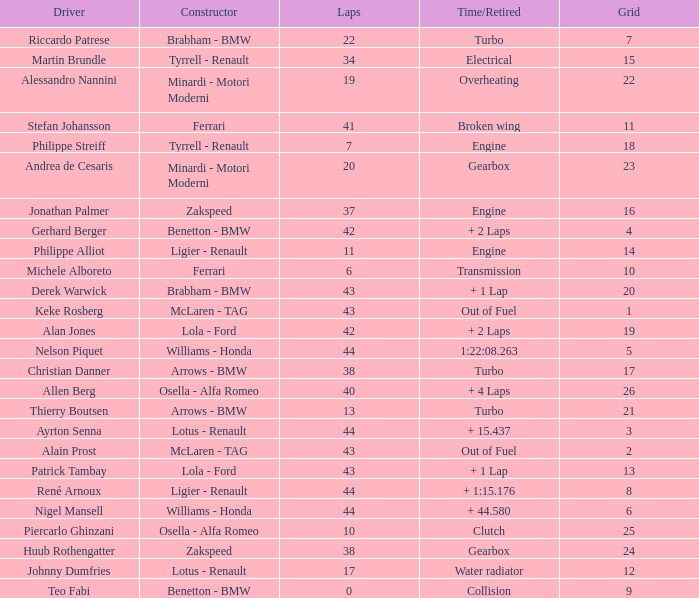I want the driver that has Laps of 10 Piercarlo Ghinzani. 